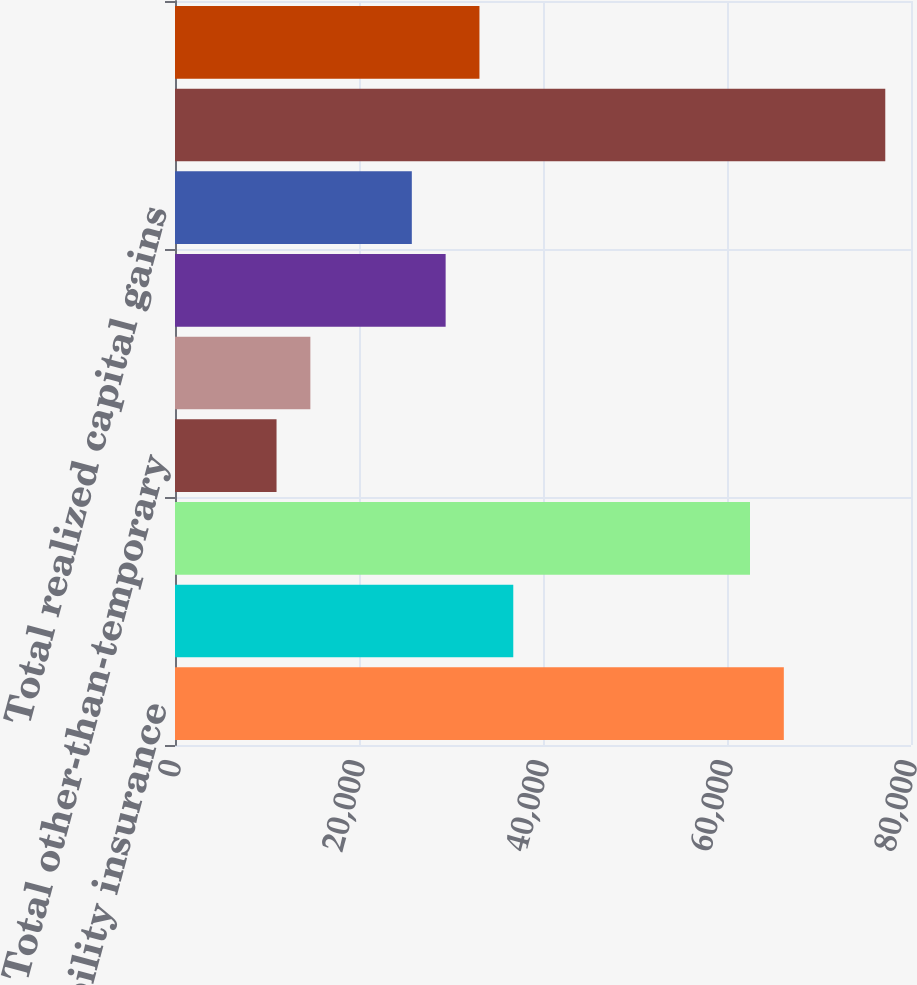<chart> <loc_0><loc_0><loc_500><loc_500><bar_chart><fcel>Property-liability insurance<fcel>Life and annuity premiums and<fcel>Net investment income<fcel>Total other-than-temporary<fcel>Net other-than-temporary<fcel>Sales and other realized<fcel>Total realized capital gains<fcel>Total revenues<fcel>Life and annuity contract<nl><fcel>66176.2<fcel>36769<fcel>62500.3<fcel>11037.7<fcel>14713.6<fcel>29417.2<fcel>25741.3<fcel>77203.9<fcel>33093.1<nl></chart> 